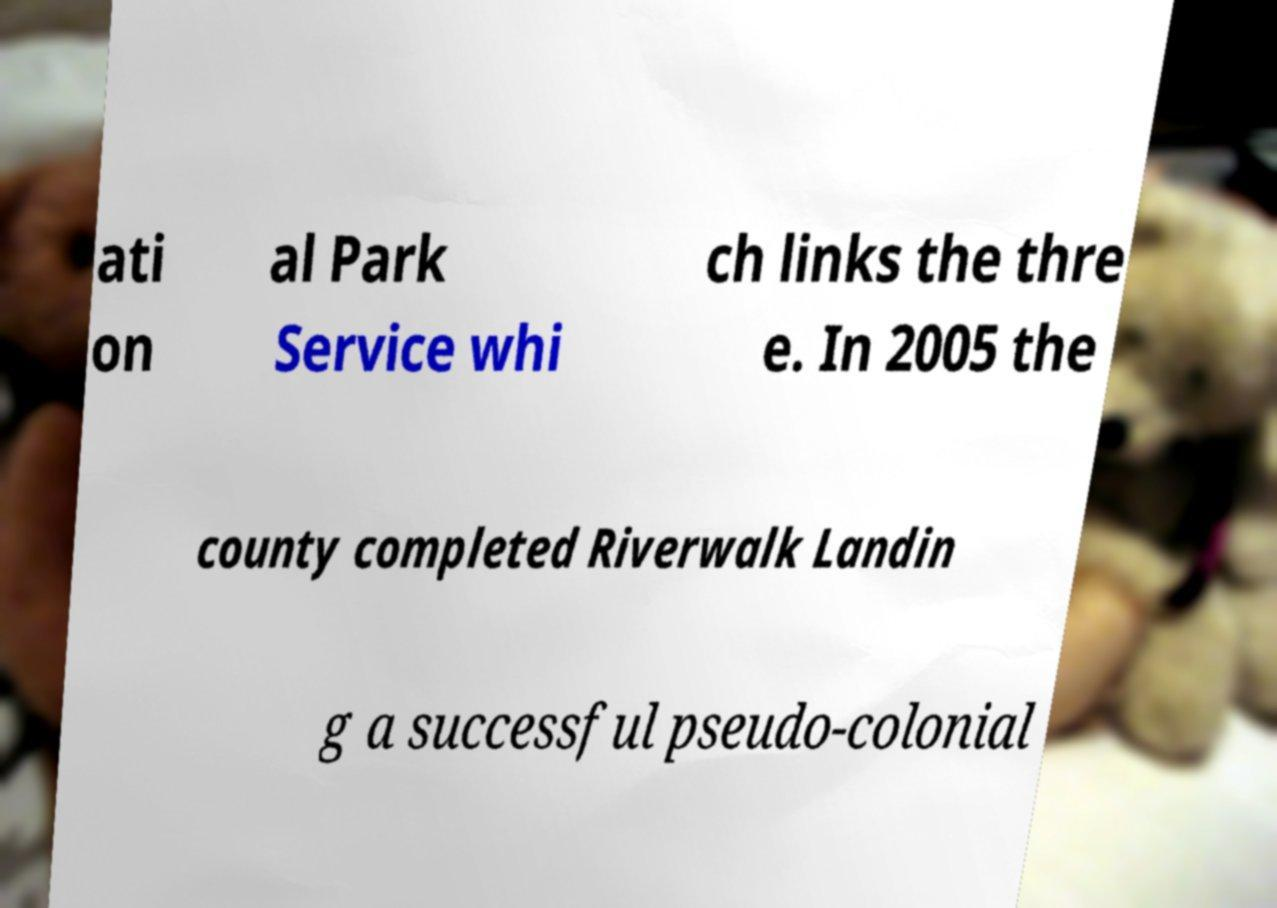I need the written content from this picture converted into text. Can you do that? ati on al Park Service whi ch links the thre e. In 2005 the county completed Riverwalk Landin g a successful pseudo-colonial 